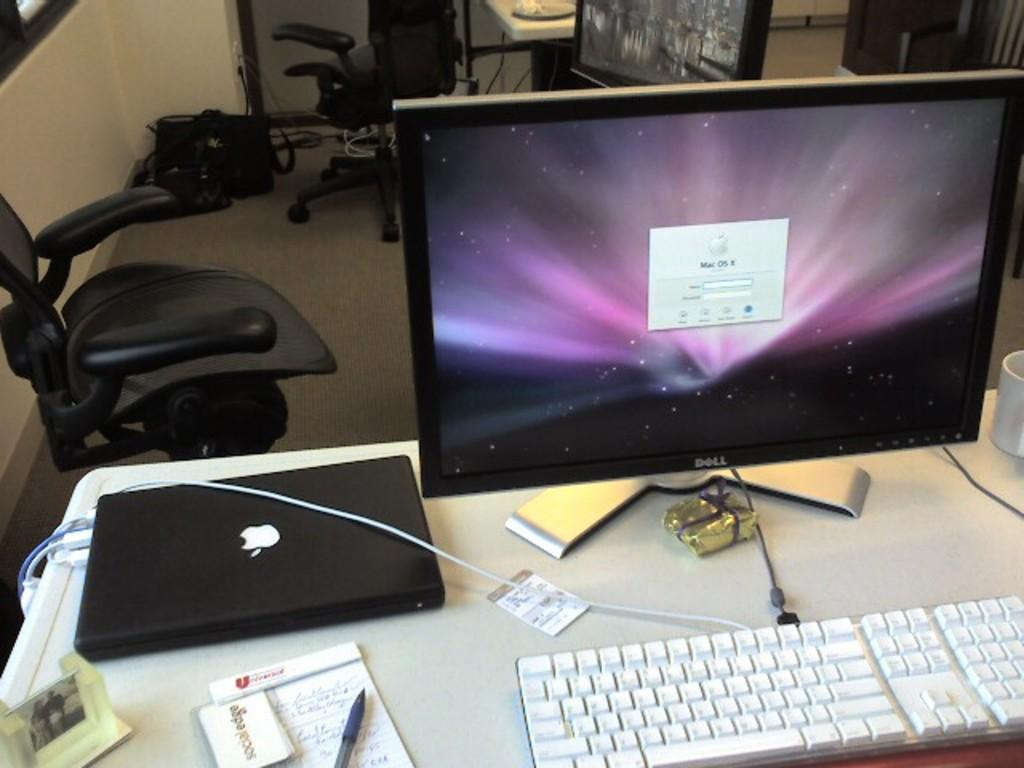Provide a one-sentence caption for the provided image. A black Apple laptop with monitor on the side. 